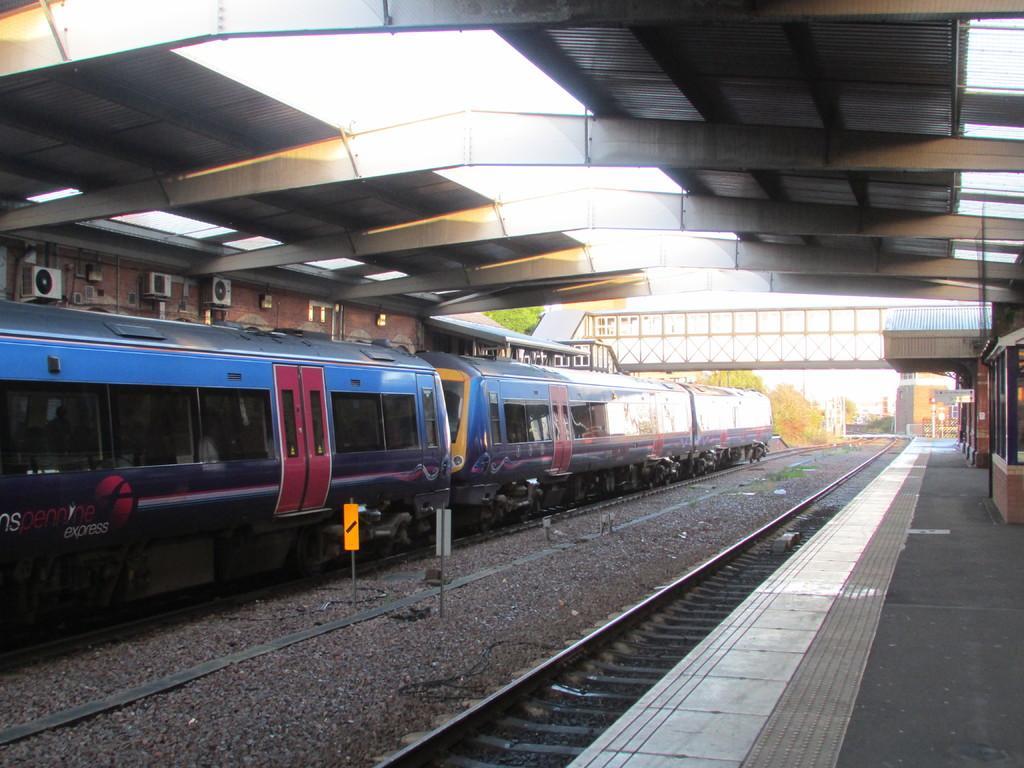How would you summarize this image in a sentence or two? In this image I can see a train is on the railway track. Train is in red,blue and yellow color. I can platform and a building. In front I can see bridge and trees. I can see a boards. 